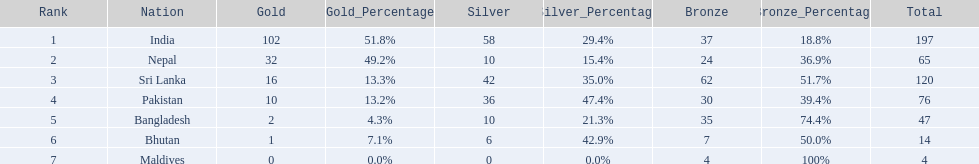How many gold medals did india win? 102. 